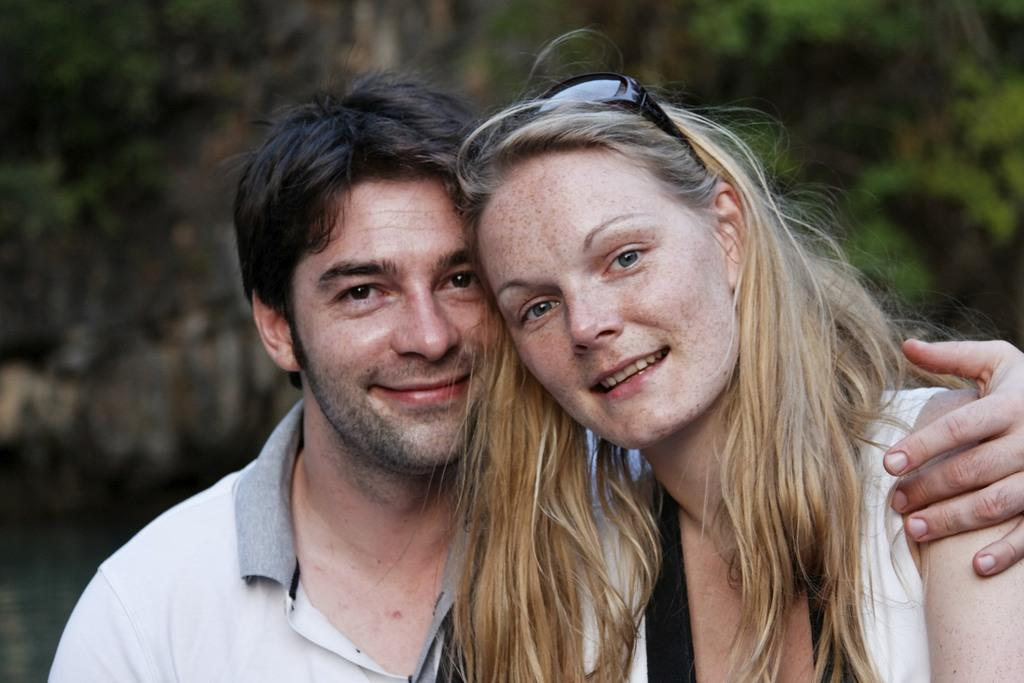How many people are in the foreground of the image? There are two people in the foreground of the image. Can you describe the appearance of the people? One person is a man on the left side, and the other person is a woman on the right side. What type of suit is the rat wearing in the image? There is no rat present in the image, and therefore no suit can be observed. 